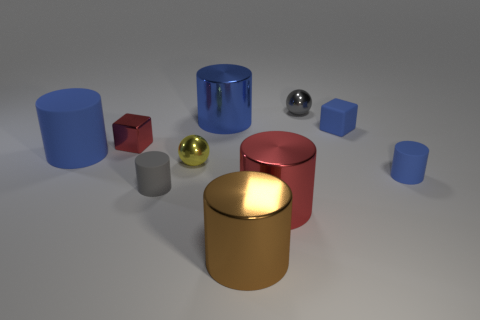What is the material of the small object that is both behind the tiny blue rubber cylinder and in front of the red block?
Provide a succinct answer. Metal. Are there any small cyan matte spheres?
Give a very brief answer. No. Is the color of the big matte cylinder the same as the block that is right of the gray matte cylinder?
Your answer should be very brief. Yes. What material is the other large cylinder that is the same color as the large rubber cylinder?
Provide a short and direct response. Metal. There is a red metal thing to the left of the ball to the left of the shiny cylinder behind the tiny blue cube; what is its shape?
Ensure brevity in your answer.  Cube. The tiny red thing has what shape?
Provide a short and direct response. Cube. There is a small metallic thing that is to the right of the blue metallic cylinder; what color is it?
Provide a succinct answer. Gray. Does the blue matte object that is left of the blue metallic cylinder have the same size as the big red thing?
Offer a very short reply. Yes. The other shiny thing that is the same shape as the small gray metallic object is what size?
Your answer should be compact. Small. Does the big blue rubber object have the same shape as the big red thing?
Offer a terse response. Yes. 